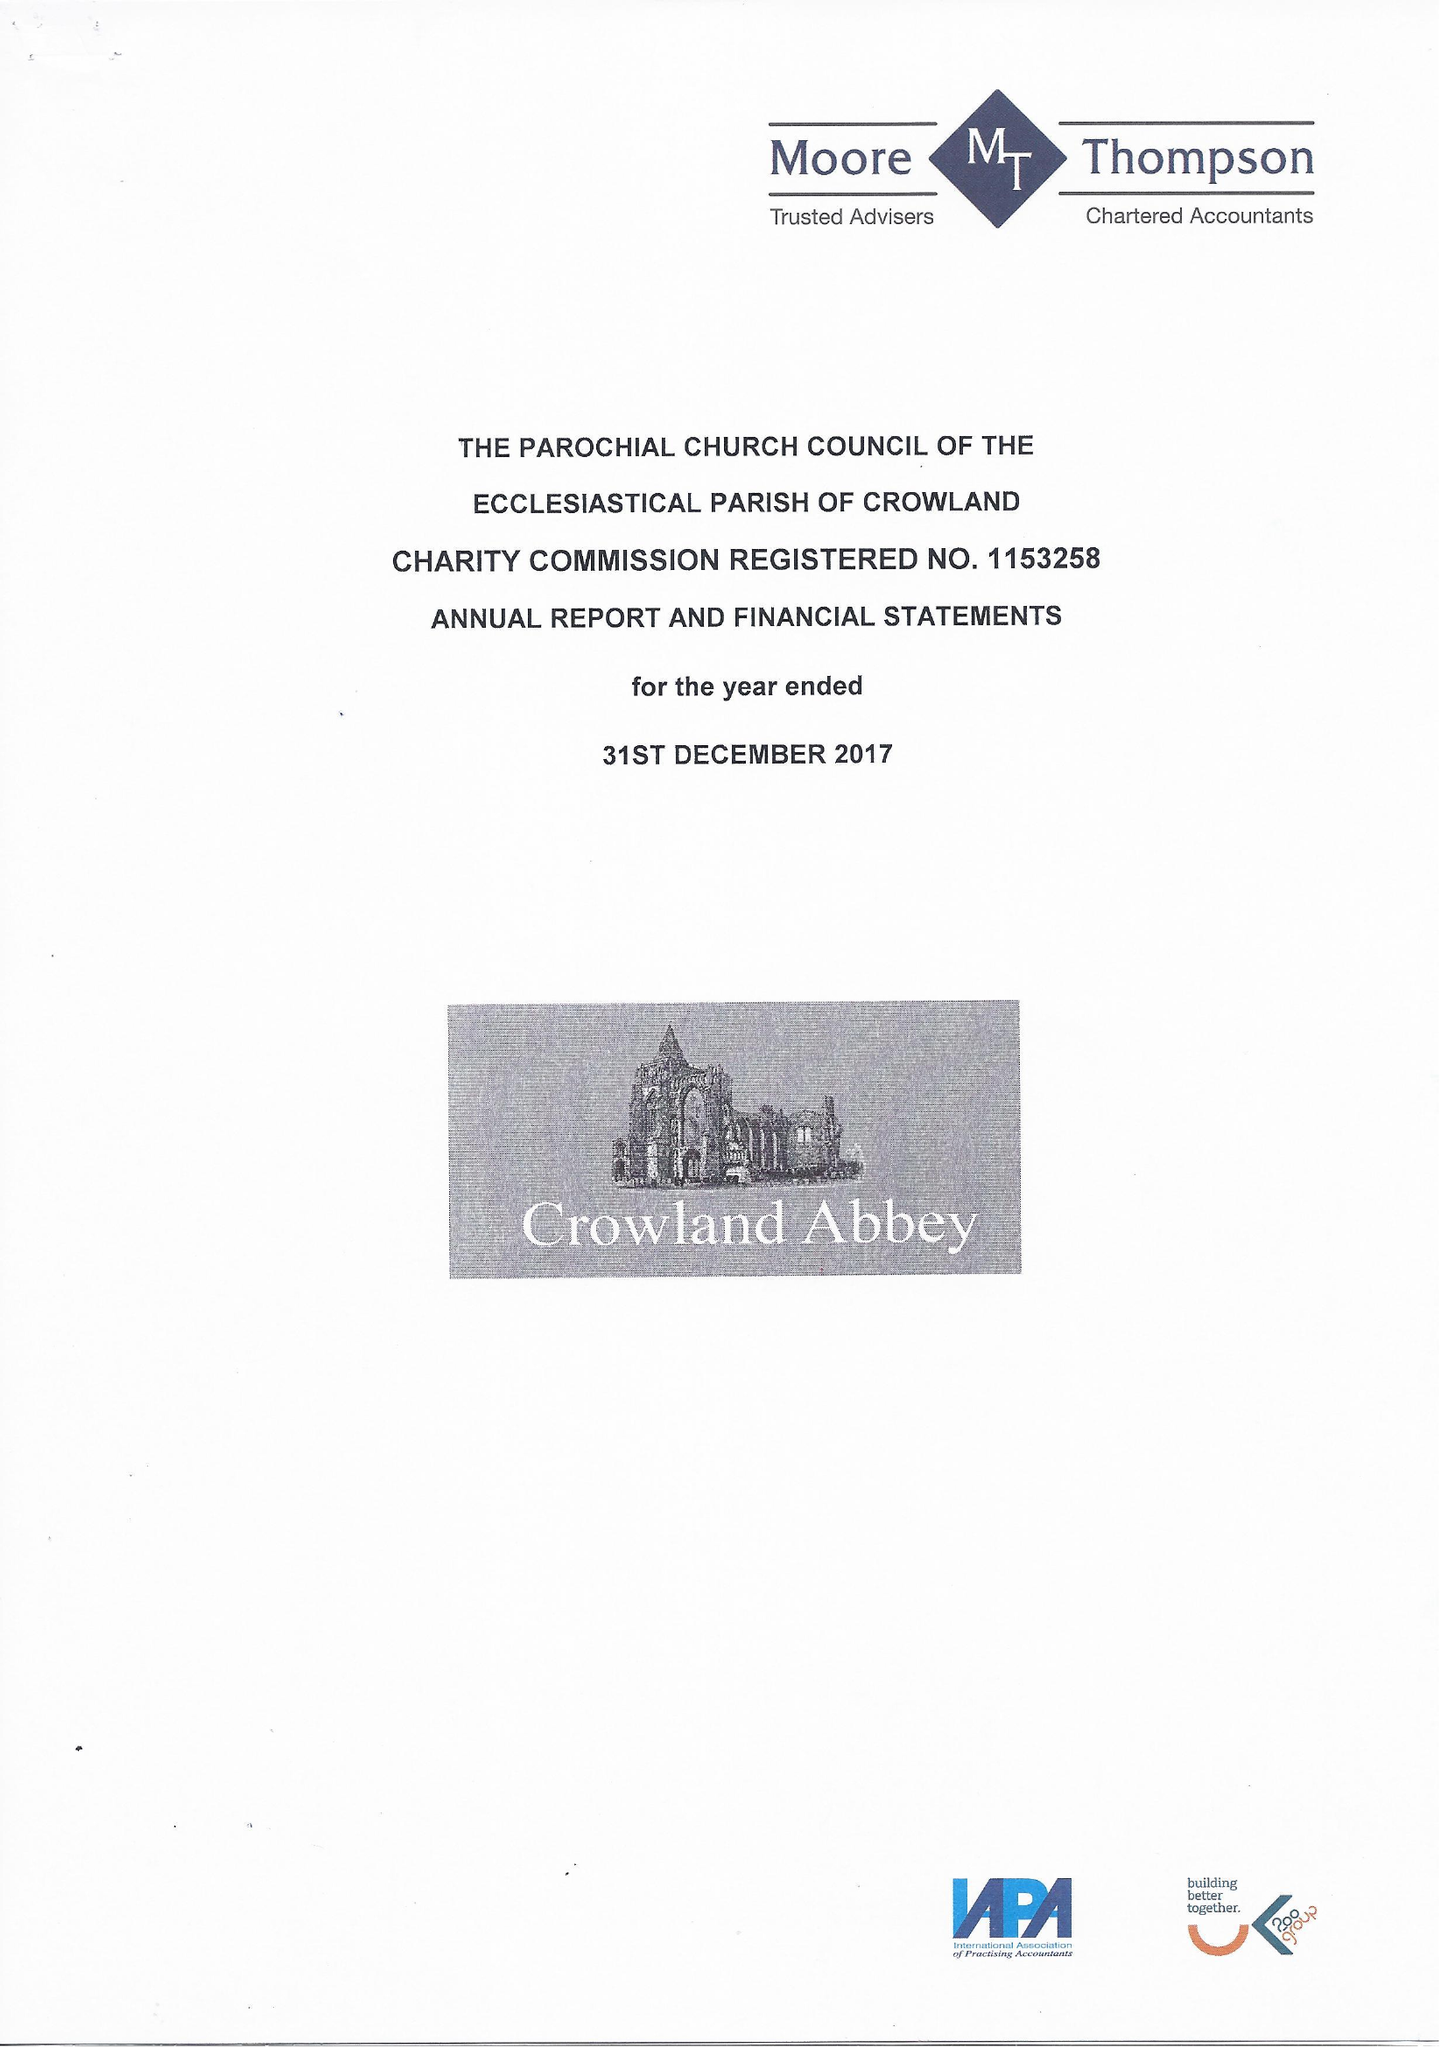What is the value for the charity_name?
Answer the question using a single word or phrase. The Parochial Church Council Of The Ecclesiastical Parish Of Crowland 